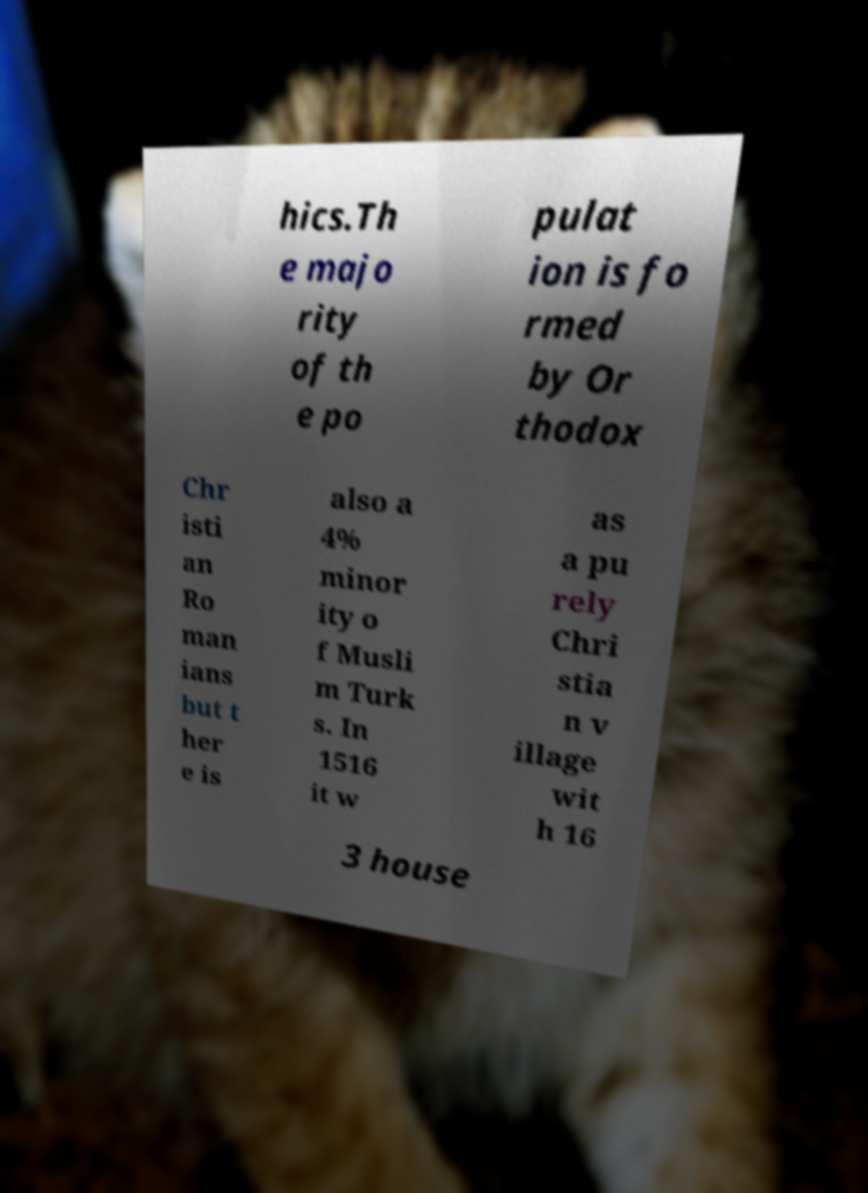I need the written content from this picture converted into text. Can you do that? hics.Th e majo rity of th e po pulat ion is fo rmed by Or thodox Chr isti an Ro man ians but t her e is also a 4% minor ity o f Musli m Turk s. In 1516 it w as a pu rely Chri stia n v illage wit h 16 3 house 